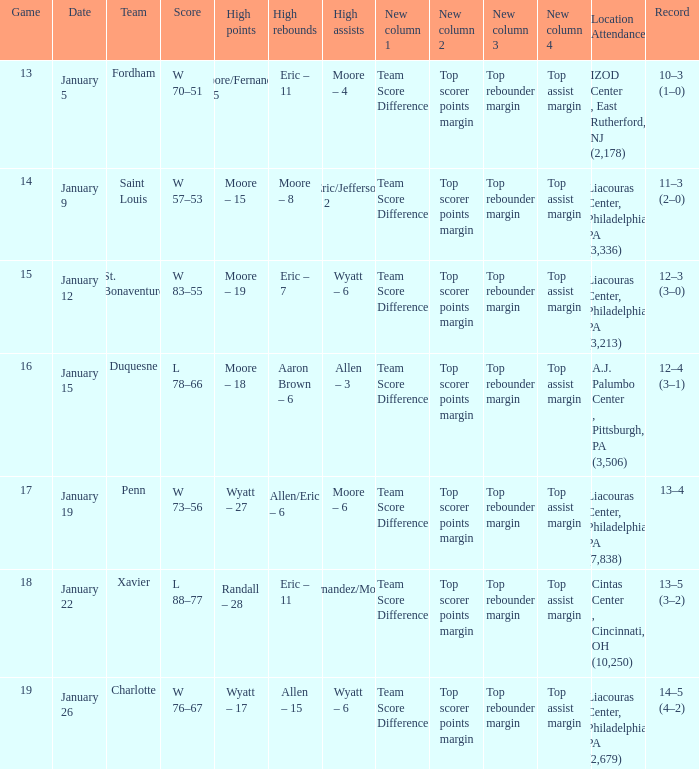Who had the most assists and how many did they have on January 5? Moore – 4. 